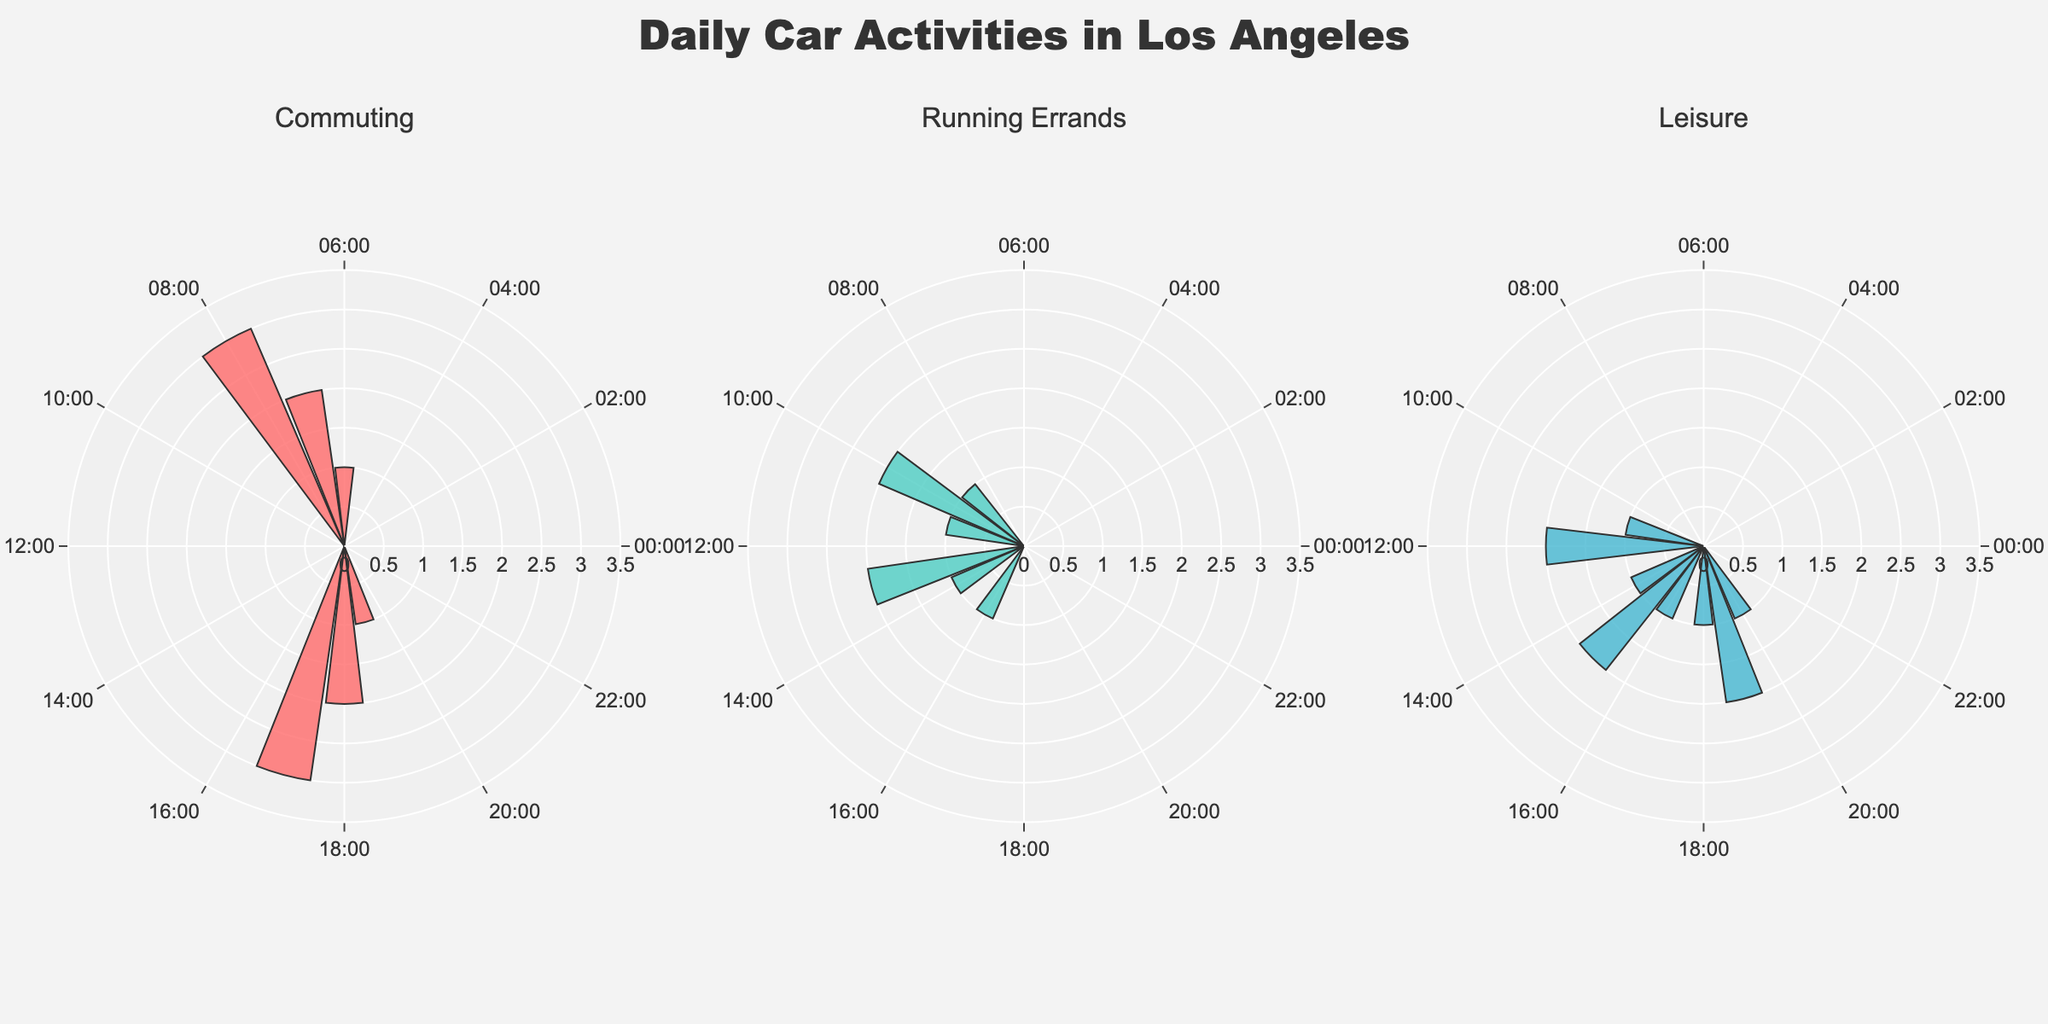What's the title of the plot? The title is placed at the top of the plot and summarizes the subject of the chart.
Answer: Daily Car Activities in Los Angeles Which activity has the most hours at 8:00 AM? At 8:00 AM in the polar subplot representing Commuting, you can visually see the highest bar compared to others.
Answer: Commuting How many hours are spent on Running Errands at 1:00 PM? Look at the subplot for Running Errands. The bar corresponding to 1:00 PM (or 13:00) indicates the number of hours.
Answer: 2 When are no car activities recorded? All subplots have zero values at certain hours. Observing these hours gives the answer.
Answer: Between 12:00 AM and 5:00 AM, 9:00 PM to 11:00 PM What is the total time spent on Leisure activities between 12:00 PM and 3:00 PM? Observe the Leisure subplot and sum the bar heights at 12:00 PM, 1:00 PM, 2:00 PM, and 3:00 PM.
Answer: 6 Compare commuting time at 7:00 AM and 5:00 PM. Which is greater? In the subplot for Commuting, compare the bars for 7:00 AM and 5:00 PM.
Answer: 5:00 PM How many data points show more than 2 hours of Commuting? Observe the Commuting subplot. Count all the bars with heights greater than 2.
Answer: 2 At what hour is Running Errands the longest? Identify the tallest bar in the Running Errands subplot and note its corresponding hour.
Answer: 10:00 AM Which activity has no recorded time between 10:00 AM and 11:00 AM? Check the subplots for Running Errands and Leisure at these time points.
Answer: Commuting What activities overlap at 6:00 PM? Look at the subplots for all activities and note which have non-zero bars at 6:00 PM.
Answer: Commuting, Leisure 